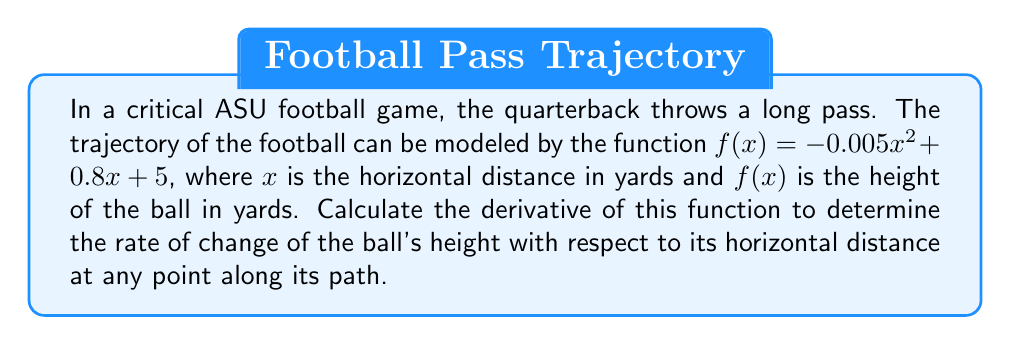Help me with this question. To find the derivative of the function $f(x) = -0.005x^2 + 0.8x + 5$, we'll use the power rule and the constant rule of differentiation.

1) First, let's break down the function into its components:
   $f(x) = -0.005x^2 + 0.8x + 5$

2) Now, let's apply the differentiation rules to each term:

   a) For $-0.005x^2$:
      The power rule states that for $ax^n$, the derivative is $nax^{n-1}$.
      Here, $a = -0.005$, $n = 2$.
      So, the derivative is: $2(-0.005)x^{2-1} = -0.01x$

   b) For $0.8x$:
      The power rule applies here too, with $n = 1$.
      The derivative is simply $0.8$.

   c) For the constant term 5:
      The derivative of a constant is always 0.

3) Combining these results, we get:
   $f'(x) = -0.01x + 0.8 + 0$

4) Simplifying:
   $f'(x) = -0.01x + 0.8$

This derivative represents the instantaneous rate of change of the ball's height with respect to its horizontal distance at any point along its trajectory. It can be used to analyze the ball's path and potentially predict where it might be caught, which is crucial for game strategy.
Answer: $f'(x) = -0.01x + 0.8$ 